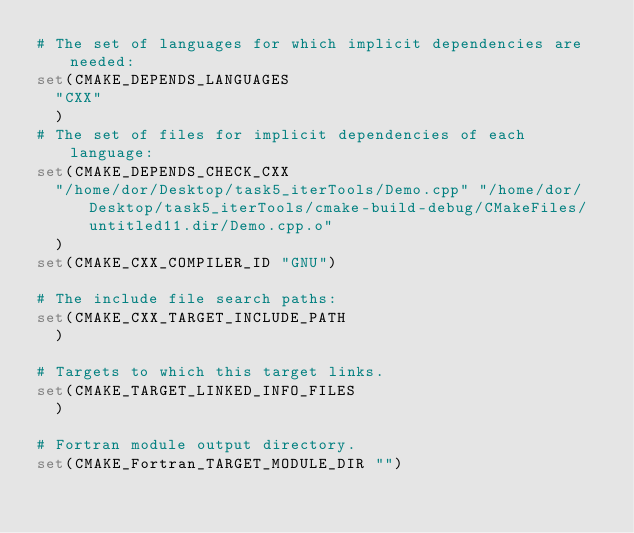Convert code to text. <code><loc_0><loc_0><loc_500><loc_500><_CMake_># The set of languages for which implicit dependencies are needed:
set(CMAKE_DEPENDS_LANGUAGES
  "CXX"
  )
# The set of files for implicit dependencies of each language:
set(CMAKE_DEPENDS_CHECK_CXX
  "/home/dor/Desktop/task5_iterTools/Demo.cpp" "/home/dor/Desktop/task5_iterTools/cmake-build-debug/CMakeFiles/untitled11.dir/Demo.cpp.o"
  )
set(CMAKE_CXX_COMPILER_ID "GNU")

# The include file search paths:
set(CMAKE_CXX_TARGET_INCLUDE_PATH
  )

# Targets to which this target links.
set(CMAKE_TARGET_LINKED_INFO_FILES
  )

# Fortran module output directory.
set(CMAKE_Fortran_TARGET_MODULE_DIR "")
</code> 